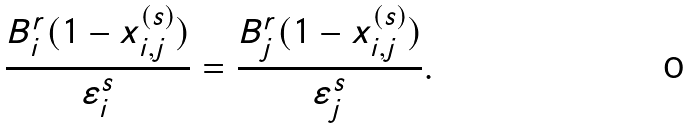<formula> <loc_0><loc_0><loc_500><loc_500>\frac { B ^ { r } _ { i } ( 1 - x ^ { ( s ) } _ { i , j } ) } { \varepsilon ^ { s } _ { i } } = \frac { B ^ { r } _ { j } ( 1 - x ^ { ( s ) } _ { i , j } ) } { \varepsilon ^ { s } _ { j } } .</formula> 